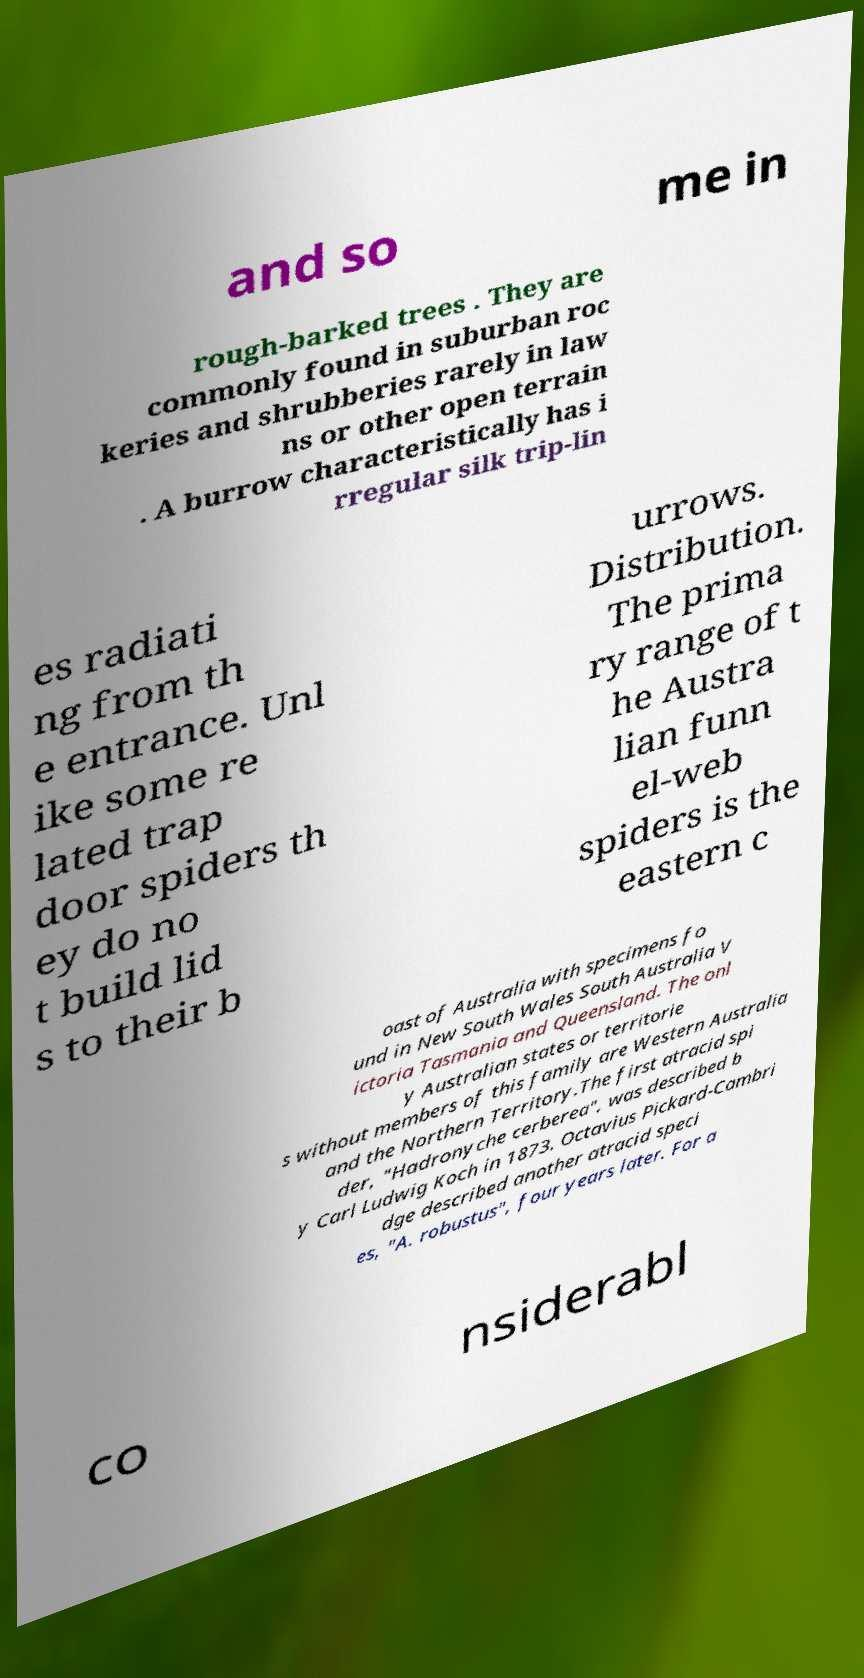Can you read and provide the text displayed in the image?This photo seems to have some interesting text. Can you extract and type it out for me? and so me in rough-barked trees . They are commonly found in suburban roc keries and shrubberies rarely in law ns or other open terrain . A burrow characteristically has i rregular silk trip-lin es radiati ng from th e entrance. Unl ike some re lated trap door spiders th ey do no t build lid s to their b urrows. Distribution. The prima ry range of t he Austra lian funn el-web spiders is the eastern c oast of Australia with specimens fo und in New South Wales South Australia V ictoria Tasmania and Queensland. The onl y Australian states or territorie s without members of this family are Western Australia and the Northern Territory.The first atracid spi der, "Hadronyche cerberea", was described b y Carl Ludwig Koch in 1873. Octavius Pickard-Cambri dge described another atracid speci es, "A. robustus", four years later. For a co nsiderabl 